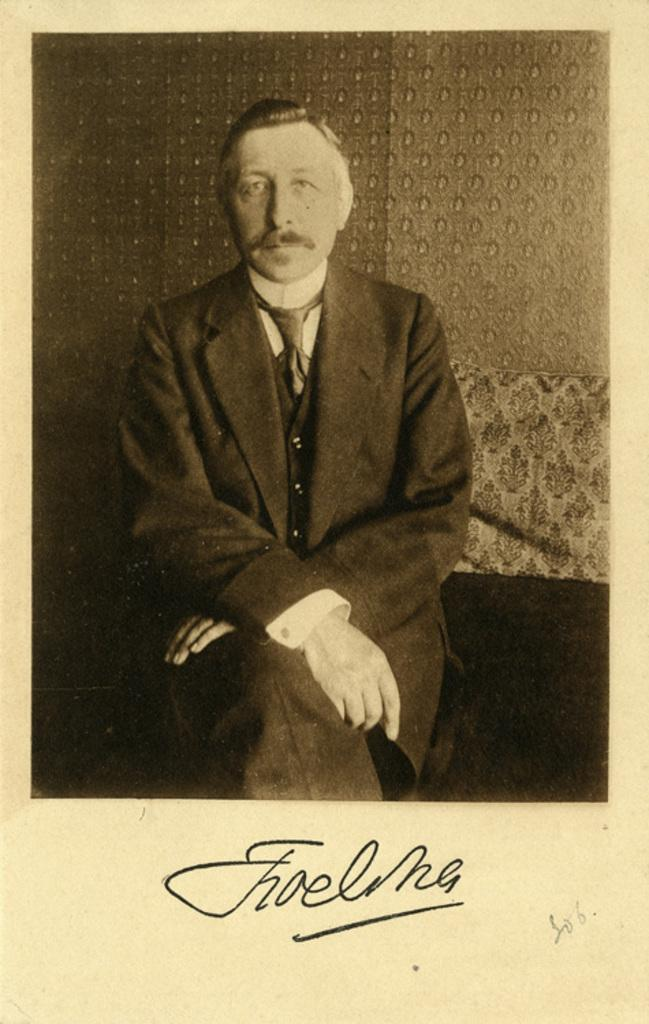What type of medium is the image a part of? The image is a page in a book. What can be seen in the picture on the page? There is a picture of a person in the image. What else is present on the page besides the picture? There is text in the image. How many buildings are visible in the image? There are no buildings visible in the image; it is a page from a book with a picture of a person and text. What achievements has the person in the image accomplished? The image does not provide information about the person's achievements, as it only shows a picture of the person and text. 